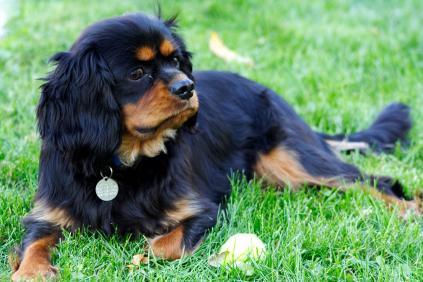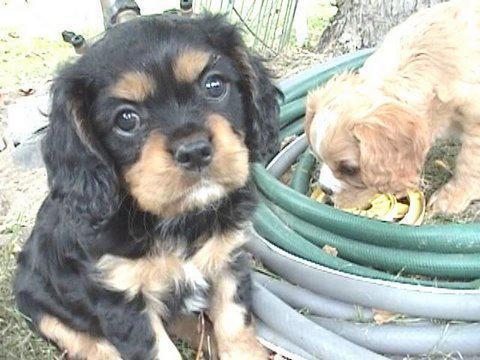The first image is the image on the left, the second image is the image on the right. For the images shown, is this caption "There are three dogs in total." true? Answer yes or no. Yes. The first image is the image on the left, the second image is the image on the right. Analyze the images presented: Is the assertion "There are three dogs." valid? Answer yes or no. Yes. 